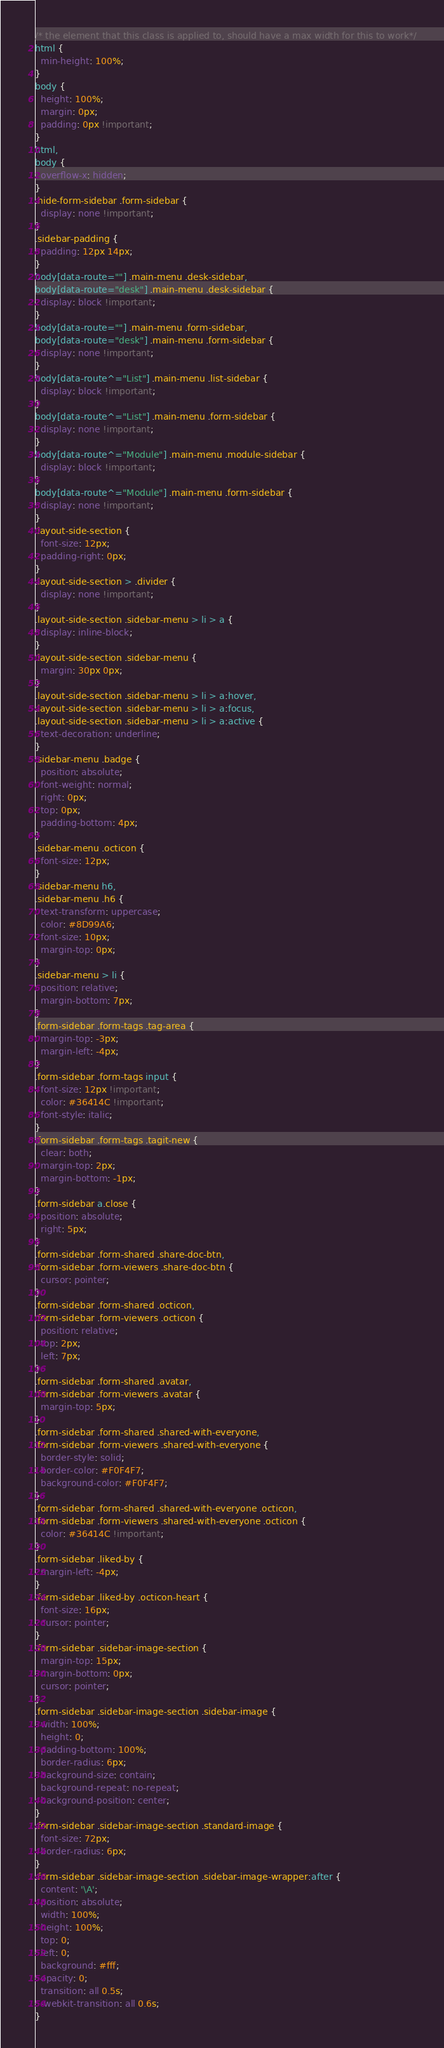Convert code to text. <code><loc_0><loc_0><loc_500><loc_500><_CSS_>/* the element that this class is applied to, should have a max width for this to work*/
html {
  min-height: 100%;
}
body {
  height: 100%;
  margin: 0px;
  padding: 0px !important;
}
html,
body {
  overflow-x: hidden;
}
.hide-form-sidebar .form-sidebar {
  display: none !important;
}
.sidebar-padding {
  padding: 12px 14px;
}
body[data-route=""] .main-menu .desk-sidebar,
body[data-route="desk"] .main-menu .desk-sidebar {
  display: block !important;
}
body[data-route=""] .main-menu .form-sidebar,
body[data-route="desk"] .main-menu .form-sidebar {
  display: none !important;
}
body[data-route^="List"] .main-menu .list-sidebar {
  display: block !important;
}
body[data-route^="List"] .main-menu .form-sidebar {
  display: none !important;
}
body[data-route^="Module"] .main-menu .module-sidebar {
  display: block !important;
}
body[data-route^="Module"] .main-menu .form-sidebar {
  display: none !important;
}
.layout-side-section {
  font-size: 12px;
  padding-right: 0px;
}
.layout-side-section > .divider {
  display: none !important;
}
.layout-side-section .sidebar-menu > li > a {
  display: inline-block;
}
.layout-side-section .sidebar-menu {
  margin: 30px 0px;
}
.layout-side-section .sidebar-menu > li > a:hover,
.layout-side-section .sidebar-menu > li > a:focus,
.layout-side-section .sidebar-menu > li > a:active {
  text-decoration: underline;
}
.sidebar-menu .badge {
  position: absolute;
  font-weight: normal;
  right: 0px;
  top: 0px;
  padding-bottom: 4px;
}
.sidebar-menu .octicon {
  font-size: 12px;
}
.sidebar-menu h6,
.sidebar-menu .h6 {
  text-transform: uppercase;
  color: #8D99A6;
  font-size: 10px;
  margin-top: 0px;
}
.sidebar-menu > li {
  position: relative;
  margin-bottom: 7px;
}
.form-sidebar .form-tags .tag-area {
  margin-top: -3px;
  margin-left: -4px;
}
.form-sidebar .form-tags input {
  font-size: 12px !important;
  color: #36414C !important;
  font-style: italic;
}
.form-sidebar .form-tags .tagit-new {
  clear: both;
  margin-top: 2px;
  margin-bottom: -1px;
}
.form-sidebar a.close {
  position: absolute;
  right: 5px;
}
.form-sidebar .form-shared .share-doc-btn,
.form-sidebar .form-viewers .share-doc-btn {
  cursor: pointer;
}
.form-sidebar .form-shared .octicon,
.form-sidebar .form-viewers .octicon {
  position: relative;
  top: 2px;
  left: 7px;
}
.form-sidebar .form-shared .avatar,
.form-sidebar .form-viewers .avatar {
  margin-top: 5px;
}
.form-sidebar .form-shared .shared-with-everyone,
.form-sidebar .form-viewers .shared-with-everyone {
  border-style: solid;
  border-color: #F0F4F7;
  background-color: #F0F4F7;
}
.form-sidebar .form-shared .shared-with-everyone .octicon,
.form-sidebar .form-viewers .shared-with-everyone .octicon {
  color: #36414C !important;
}
.form-sidebar .liked-by {
  margin-left: -4px;
}
.form-sidebar .liked-by .octicon-heart {
  font-size: 16px;
  cursor: pointer;
}
.form-sidebar .sidebar-image-section {
  margin-top: 15px;
  margin-bottom: 0px;
  cursor: pointer;
}
.form-sidebar .sidebar-image-section .sidebar-image {
  width: 100%;
  height: 0;
  padding-bottom: 100%;
  border-radius: 6px;
  background-size: contain;
  background-repeat: no-repeat;
  background-position: center;
}
.form-sidebar .sidebar-image-section .standard-image {
  font-size: 72px;
  border-radius: 6px;
}
.form-sidebar .sidebar-image-section .sidebar-image-wrapper:after {
  content: '\A';
  position: absolute;
  width: 100%;
  height: 100%;
  top: 0;
  left: 0;
  background: #fff;
  opacity: 0;
  transition: all 0.5s;
  -webkit-transition: all 0.6s;
}</code> 